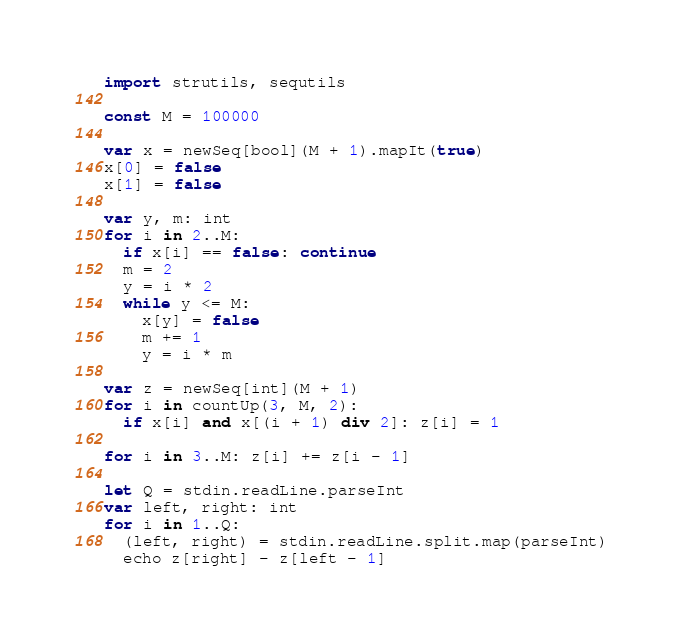<code> <loc_0><loc_0><loc_500><loc_500><_Nim_>import strutils, sequtils

const M = 100000

var x = newSeq[bool](M + 1).mapIt(true)
x[0] = false
x[1] = false

var y, m: int
for i in 2..M:
  if x[i] == false: continue
  m = 2
  y = i * 2
  while y <= M:
    x[y] = false
    m += 1
    y = i * m

var z = newSeq[int](M + 1)
for i in countUp(3, M, 2):
  if x[i] and x[(i + 1) div 2]: z[i] = 1

for i in 3..M: z[i] += z[i - 1]

let Q = stdin.readLine.parseInt
var left, right: int
for i in 1..Q:
  (left, right) = stdin.readLine.split.map(parseInt)
  echo z[right] - z[left - 1]
</code> 